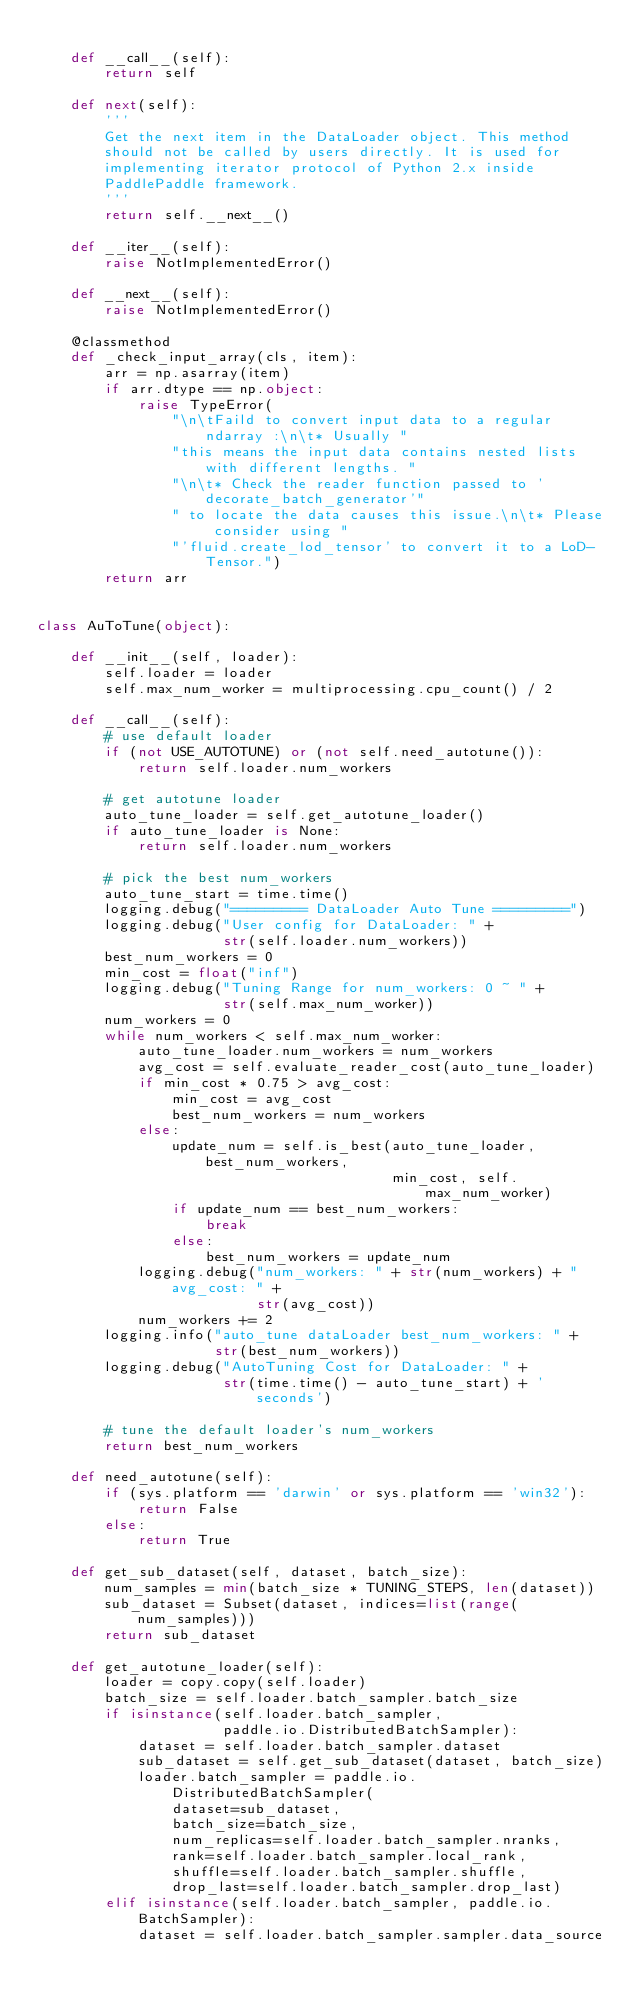Convert code to text. <code><loc_0><loc_0><loc_500><loc_500><_Python_>
    def __call__(self):
        return self

    def next(self):
        '''
        Get the next item in the DataLoader object. This method    
        should not be called by users directly. It is used for
        implementing iterator protocol of Python 2.x inside
        PaddlePaddle framework.
        '''
        return self.__next__()

    def __iter__(self):
        raise NotImplementedError()

    def __next__(self):
        raise NotImplementedError()

    @classmethod
    def _check_input_array(cls, item):
        arr = np.asarray(item)
        if arr.dtype == np.object:
            raise TypeError(
                "\n\tFaild to convert input data to a regular ndarray :\n\t* Usually "
                "this means the input data contains nested lists with different lengths. "
                "\n\t* Check the reader function passed to 'decorate_batch_generator'"
                " to locate the data causes this issue.\n\t* Please consider using "
                "'fluid.create_lod_tensor' to convert it to a LoD-Tensor.")
        return arr


class AuToTune(object):

    def __init__(self, loader):
        self.loader = loader
        self.max_num_worker = multiprocessing.cpu_count() / 2

    def __call__(self):
        # use default loader
        if (not USE_AUTOTUNE) or (not self.need_autotune()):
            return self.loader.num_workers

        # get autotune loader
        auto_tune_loader = self.get_autotune_loader()
        if auto_tune_loader is None:
            return self.loader.num_workers

        # pick the best num_workers
        auto_tune_start = time.time()
        logging.debug("========= DataLoader Auto Tune =========")
        logging.debug("User config for DataLoader: " +
                      str(self.loader.num_workers))
        best_num_workers = 0
        min_cost = float("inf")
        logging.debug("Tuning Range for num_workers: 0 ~ " +
                      str(self.max_num_worker))
        num_workers = 0
        while num_workers < self.max_num_worker:
            auto_tune_loader.num_workers = num_workers
            avg_cost = self.evaluate_reader_cost(auto_tune_loader)
            if min_cost * 0.75 > avg_cost:
                min_cost = avg_cost
                best_num_workers = num_workers
            else:
                update_num = self.is_best(auto_tune_loader, best_num_workers,
                                          min_cost, self.max_num_worker)
                if update_num == best_num_workers:
                    break
                else:
                    best_num_workers = update_num
            logging.debug("num_workers: " + str(num_workers) + " avg_cost: " +
                          str(avg_cost))
            num_workers += 2
        logging.info("auto_tune dataLoader best_num_workers: " +
                     str(best_num_workers))
        logging.debug("AutoTuning Cost for DataLoader: " +
                      str(time.time() - auto_tune_start) + ' seconds')

        # tune the default loader's num_workers
        return best_num_workers

    def need_autotune(self):
        if (sys.platform == 'darwin' or sys.platform == 'win32'):
            return False
        else:
            return True

    def get_sub_dataset(self, dataset, batch_size):
        num_samples = min(batch_size * TUNING_STEPS, len(dataset))
        sub_dataset = Subset(dataset, indices=list(range(num_samples)))
        return sub_dataset

    def get_autotune_loader(self):
        loader = copy.copy(self.loader)
        batch_size = self.loader.batch_sampler.batch_size
        if isinstance(self.loader.batch_sampler,
                      paddle.io.DistributedBatchSampler):
            dataset = self.loader.batch_sampler.dataset
            sub_dataset = self.get_sub_dataset(dataset, batch_size)
            loader.batch_sampler = paddle.io.DistributedBatchSampler(
                dataset=sub_dataset,
                batch_size=batch_size,
                num_replicas=self.loader.batch_sampler.nranks,
                rank=self.loader.batch_sampler.local_rank,
                shuffle=self.loader.batch_sampler.shuffle,
                drop_last=self.loader.batch_sampler.drop_last)
        elif isinstance(self.loader.batch_sampler, paddle.io.BatchSampler):
            dataset = self.loader.batch_sampler.sampler.data_source</code> 